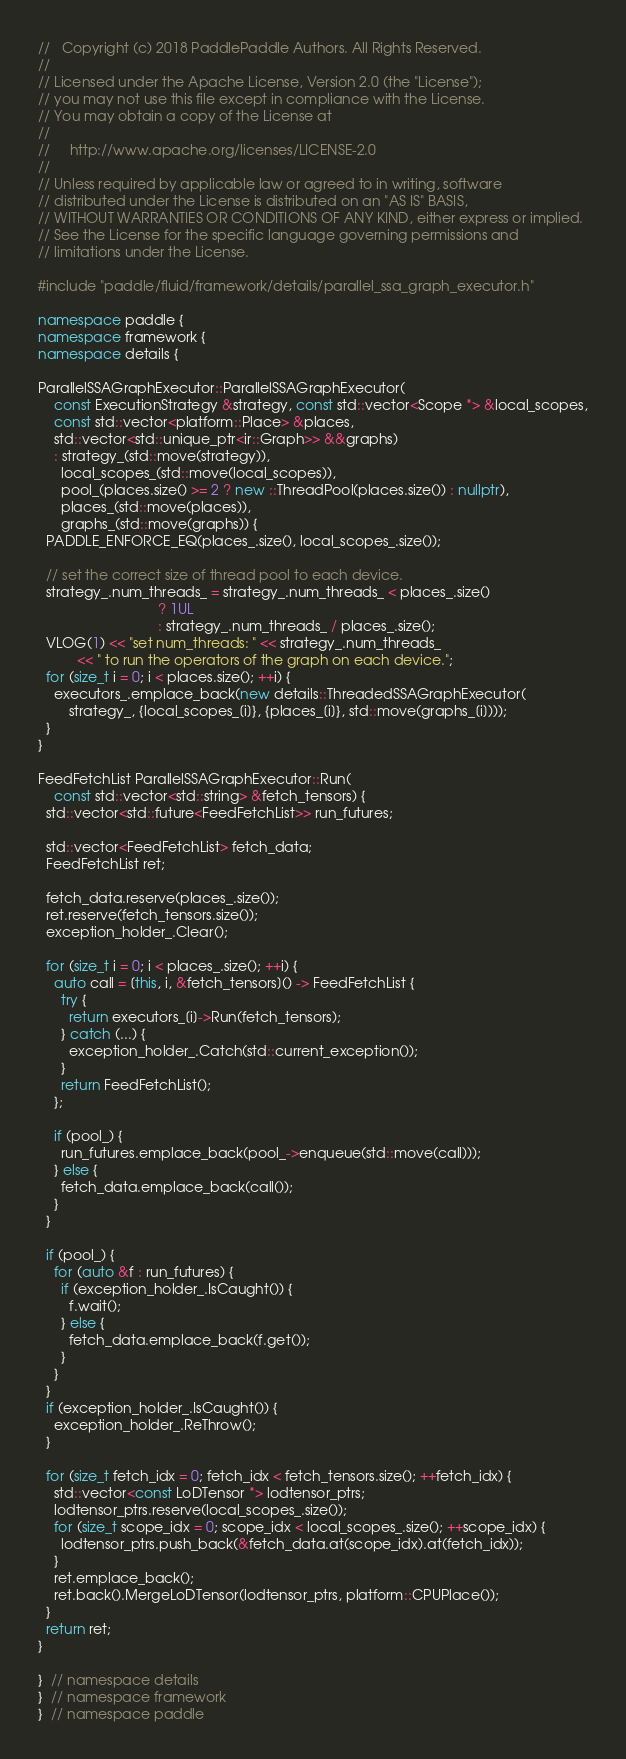<code> <loc_0><loc_0><loc_500><loc_500><_C++_>//   Copyright (c) 2018 PaddlePaddle Authors. All Rights Reserved.
//
// Licensed under the Apache License, Version 2.0 (the "License");
// you may not use this file except in compliance with the License.
// You may obtain a copy of the License at
//
//     http://www.apache.org/licenses/LICENSE-2.0
//
// Unless required by applicable law or agreed to in writing, software
// distributed under the License is distributed on an "AS IS" BASIS,
// WITHOUT WARRANTIES OR CONDITIONS OF ANY KIND, either express or implied.
// See the License for the specific language governing permissions and
// limitations under the License.

#include "paddle/fluid/framework/details/parallel_ssa_graph_executor.h"

namespace paddle {
namespace framework {
namespace details {

ParallelSSAGraphExecutor::ParallelSSAGraphExecutor(
    const ExecutionStrategy &strategy, const std::vector<Scope *> &local_scopes,
    const std::vector<platform::Place> &places,
    std::vector<std::unique_ptr<ir::Graph>> &&graphs)
    : strategy_(std::move(strategy)),
      local_scopes_(std::move(local_scopes)),
      pool_(places.size() >= 2 ? new ::ThreadPool(places.size()) : nullptr),
      places_(std::move(places)),
      graphs_(std::move(graphs)) {
  PADDLE_ENFORCE_EQ(places_.size(), local_scopes_.size());

  // set the correct size of thread pool to each device.
  strategy_.num_threads_ = strategy_.num_threads_ < places_.size()
                               ? 1UL
                               : strategy_.num_threads_ / places_.size();
  VLOG(1) << "set num_threads: " << strategy_.num_threads_
          << " to run the operators of the graph on each device.";
  for (size_t i = 0; i < places.size(); ++i) {
    executors_.emplace_back(new details::ThreadedSSAGraphExecutor(
        strategy_, {local_scopes_[i]}, {places_[i]}, std::move(graphs_[i])));
  }
}

FeedFetchList ParallelSSAGraphExecutor::Run(
    const std::vector<std::string> &fetch_tensors) {
  std::vector<std::future<FeedFetchList>> run_futures;

  std::vector<FeedFetchList> fetch_data;
  FeedFetchList ret;

  fetch_data.reserve(places_.size());
  ret.reserve(fetch_tensors.size());
  exception_holder_.Clear();

  for (size_t i = 0; i < places_.size(); ++i) {
    auto call = [this, i, &fetch_tensors]() -> FeedFetchList {
      try {
        return executors_[i]->Run(fetch_tensors);
      } catch (...) {
        exception_holder_.Catch(std::current_exception());
      }
      return FeedFetchList();
    };

    if (pool_) {
      run_futures.emplace_back(pool_->enqueue(std::move(call)));
    } else {
      fetch_data.emplace_back(call());
    }
  }

  if (pool_) {
    for (auto &f : run_futures) {
      if (exception_holder_.IsCaught()) {
        f.wait();
      } else {
        fetch_data.emplace_back(f.get());
      }
    }
  }
  if (exception_holder_.IsCaught()) {
    exception_holder_.ReThrow();
  }

  for (size_t fetch_idx = 0; fetch_idx < fetch_tensors.size(); ++fetch_idx) {
    std::vector<const LoDTensor *> lodtensor_ptrs;
    lodtensor_ptrs.reserve(local_scopes_.size());
    for (size_t scope_idx = 0; scope_idx < local_scopes_.size(); ++scope_idx) {
      lodtensor_ptrs.push_back(&fetch_data.at(scope_idx).at(fetch_idx));
    }
    ret.emplace_back();
    ret.back().MergeLoDTensor(lodtensor_ptrs, platform::CPUPlace());
  }
  return ret;
}

}  // namespace details
}  // namespace framework
}  // namespace paddle
</code> 